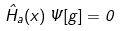Convert formula to latex. <formula><loc_0><loc_0><loc_500><loc_500>\hat { H } _ { a } ( x ) \, \Psi [ g ] = 0</formula> 